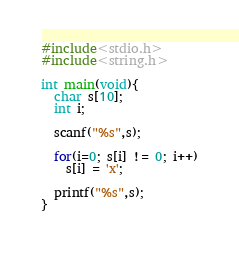<code> <loc_0><loc_0><loc_500><loc_500><_C_>#include<stdio.h>
#include<string.h>

int main(void){
  char s[10];
  int i;
  
  scanf("%s",s);
  
  for(i=0; s[i] != 0; i++)
   	s[i] = 'x';
  
  printf("%s",s);
}
  </code> 